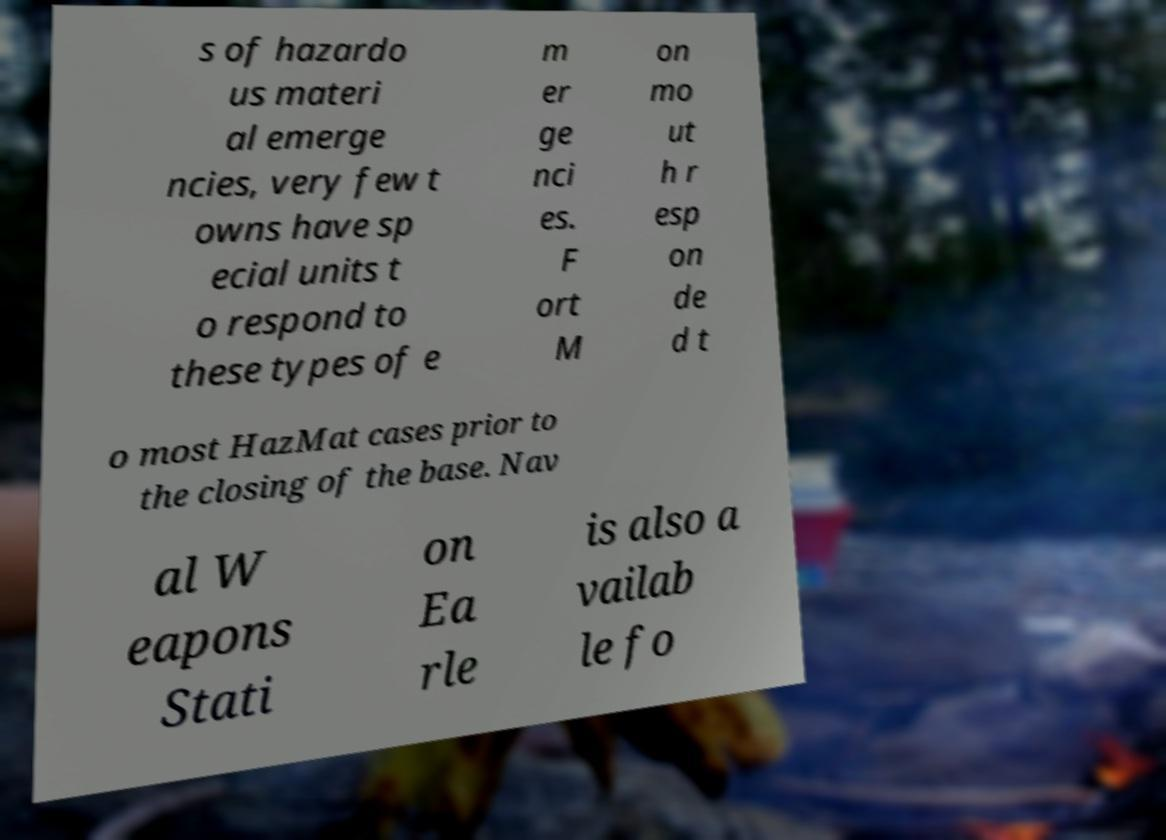Please read and relay the text visible in this image. What does it say? s of hazardo us materi al emerge ncies, very few t owns have sp ecial units t o respond to these types of e m er ge nci es. F ort M on mo ut h r esp on de d t o most HazMat cases prior to the closing of the base. Nav al W eapons Stati on Ea rle is also a vailab le fo 